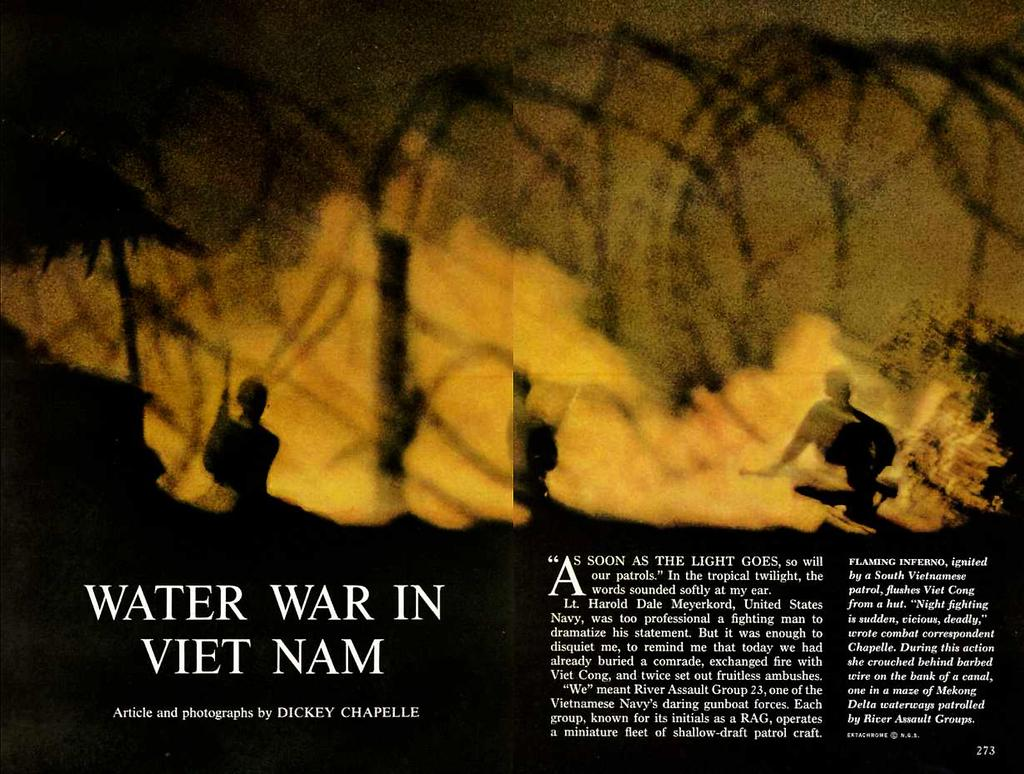<image>
Present a compact description of the photo's key features. Water War in Vietnam Article and photographs by Dickey Chapelle. 